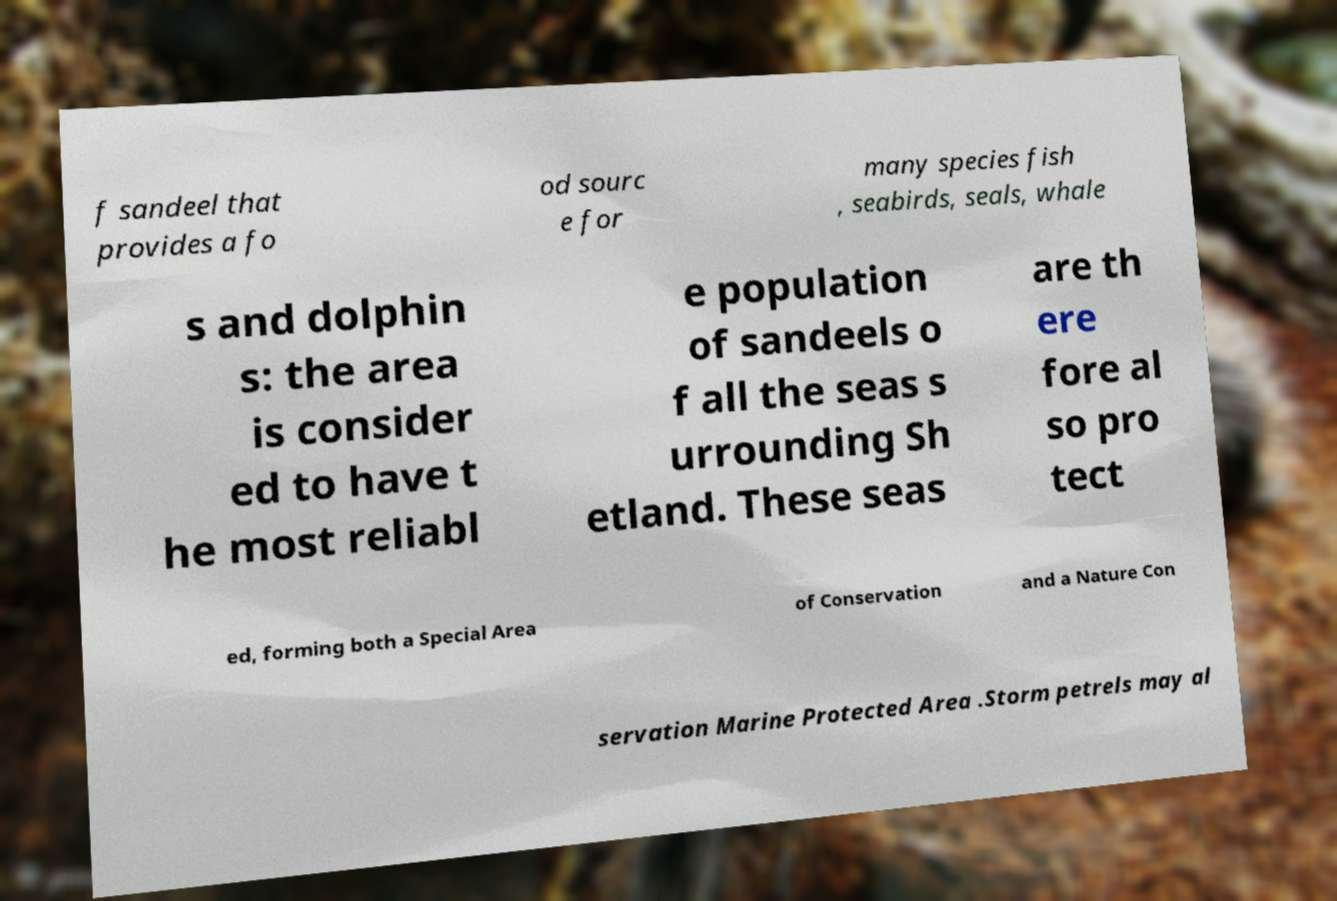For documentation purposes, I need the text within this image transcribed. Could you provide that? f sandeel that provides a fo od sourc e for many species fish , seabirds, seals, whale s and dolphin s: the area is consider ed to have t he most reliabl e population of sandeels o f all the seas s urrounding Sh etland. These seas are th ere fore al so pro tect ed, forming both a Special Area of Conservation and a Nature Con servation Marine Protected Area .Storm petrels may al 